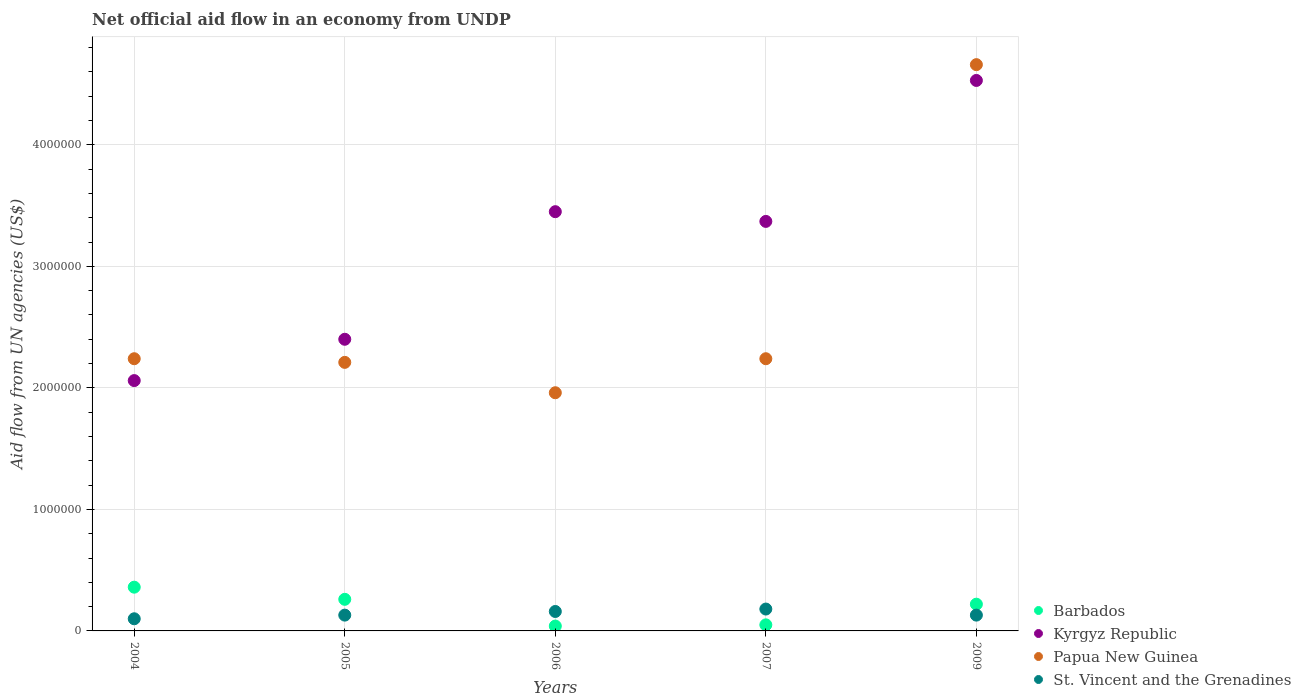Is the number of dotlines equal to the number of legend labels?
Offer a very short reply. Yes. What is the net official aid flow in Papua New Guinea in 2006?
Provide a short and direct response. 1.96e+06. Across all years, what is the minimum net official aid flow in Papua New Guinea?
Ensure brevity in your answer.  1.96e+06. In which year was the net official aid flow in Kyrgyz Republic maximum?
Provide a succinct answer. 2009. What is the total net official aid flow in Papua New Guinea in the graph?
Give a very brief answer. 1.33e+07. What is the difference between the net official aid flow in Barbados in 2004 and that in 2006?
Offer a terse response. 3.20e+05. What is the difference between the net official aid flow in St. Vincent and the Grenadines in 2006 and the net official aid flow in Papua New Guinea in 2005?
Offer a terse response. -2.05e+06. What is the average net official aid flow in Kyrgyz Republic per year?
Give a very brief answer. 3.16e+06. In the year 2004, what is the difference between the net official aid flow in St. Vincent and the Grenadines and net official aid flow in Kyrgyz Republic?
Provide a short and direct response. -1.96e+06. In how many years, is the net official aid flow in Barbados greater than 3200000 US$?
Your answer should be very brief. 0. What is the ratio of the net official aid flow in Kyrgyz Republic in 2006 to that in 2007?
Offer a very short reply. 1.02. Is the difference between the net official aid flow in St. Vincent and the Grenadines in 2004 and 2009 greater than the difference between the net official aid flow in Kyrgyz Republic in 2004 and 2009?
Make the answer very short. Yes. What is the difference between the highest and the second highest net official aid flow in Barbados?
Ensure brevity in your answer.  1.00e+05. Is the sum of the net official aid flow in Kyrgyz Republic in 2006 and 2007 greater than the maximum net official aid flow in Papua New Guinea across all years?
Give a very brief answer. Yes. Is it the case that in every year, the sum of the net official aid flow in Kyrgyz Republic and net official aid flow in Barbados  is greater than the sum of net official aid flow in Papua New Guinea and net official aid flow in St. Vincent and the Grenadines?
Provide a short and direct response. No. Is it the case that in every year, the sum of the net official aid flow in Barbados and net official aid flow in Papua New Guinea  is greater than the net official aid flow in St. Vincent and the Grenadines?
Offer a terse response. Yes. Does the net official aid flow in Papua New Guinea monotonically increase over the years?
Provide a short and direct response. No. Is the net official aid flow in Barbados strictly less than the net official aid flow in Papua New Guinea over the years?
Your answer should be very brief. Yes. Are the values on the major ticks of Y-axis written in scientific E-notation?
Your answer should be very brief. No. How many legend labels are there?
Your answer should be very brief. 4. How are the legend labels stacked?
Give a very brief answer. Vertical. What is the title of the graph?
Provide a succinct answer. Net official aid flow in an economy from UNDP. Does "Slovenia" appear as one of the legend labels in the graph?
Give a very brief answer. No. What is the label or title of the X-axis?
Your answer should be compact. Years. What is the label or title of the Y-axis?
Your answer should be very brief. Aid flow from UN agencies (US$). What is the Aid flow from UN agencies (US$) of Barbados in 2004?
Ensure brevity in your answer.  3.60e+05. What is the Aid flow from UN agencies (US$) of Kyrgyz Republic in 2004?
Give a very brief answer. 2.06e+06. What is the Aid flow from UN agencies (US$) of Papua New Guinea in 2004?
Your answer should be very brief. 2.24e+06. What is the Aid flow from UN agencies (US$) in Kyrgyz Republic in 2005?
Offer a very short reply. 2.40e+06. What is the Aid flow from UN agencies (US$) in Papua New Guinea in 2005?
Ensure brevity in your answer.  2.21e+06. What is the Aid flow from UN agencies (US$) of St. Vincent and the Grenadines in 2005?
Provide a succinct answer. 1.30e+05. What is the Aid flow from UN agencies (US$) of Barbados in 2006?
Your response must be concise. 4.00e+04. What is the Aid flow from UN agencies (US$) of Kyrgyz Republic in 2006?
Ensure brevity in your answer.  3.45e+06. What is the Aid flow from UN agencies (US$) in Papua New Guinea in 2006?
Give a very brief answer. 1.96e+06. What is the Aid flow from UN agencies (US$) of St. Vincent and the Grenadines in 2006?
Provide a succinct answer. 1.60e+05. What is the Aid flow from UN agencies (US$) of Barbados in 2007?
Offer a very short reply. 5.00e+04. What is the Aid flow from UN agencies (US$) in Kyrgyz Republic in 2007?
Ensure brevity in your answer.  3.37e+06. What is the Aid flow from UN agencies (US$) in Papua New Guinea in 2007?
Provide a short and direct response. 2.24e+06. What is the Aid flow from UN agencies (US$) of St. Vincent and the Grenadines in 2007?
Your answer should be compact. 1.80e+05. What is the Aid flow from UN agencies (US$) of Kyrgyz Republic in 2009?
Provide a short and direct response. 4.53e+06. What is the Aid flow from UN agencies (US$) in Papua New Guinea in 2009?
Your answer should be very brief. 4.66e+06. What is the Aid flow from UN agencies (US$) of St. Vincent and the Grenadines in 2009?
Make the answer very short. 1.30e+05. Across all years, what is the maximum Aid flow from UN agencies (US$) of Kyrgyz Republic?
Your answer should be very brief. 4.53e+06. Across all years, what is the maximum Aid flow from UN agencies (US$) of Papua New Guinea?
Offer a very short reply. 4.66e+06. Across all years, what is the maximum Aid flow from UN agencies (US$) of St. Vincent and the Grenadines?
Your response must be concise. 1.80e+05. Across all years, what is the minimum Aid flow from UN agencies (US$) of Kyrgyz Republic?
Your answer should be very brief. 2.06e+06. Across all years, what is the minimum Aid flow from UN agencies (US$) in Papua New Guinea?
Your answer should be compact. 1.96e+06. Across all years, what is the minimum Aid flow from UN agencies (US$) in St. Vincent and the Grenadines?
Your answer should be compact. 1.00e+05. What is the total Aid flow from UN agencies (US$) of Barbados in the graph?
Your answer should be compact. 9.30e+05. What is the total Aid flow from UN agencies (US$) in Kyrgyz Republic in the graph?
Ensure brevity in your answer.  1.58e+07. What is the total Aid flow from UN agencies (US$) of Papua New Guinea in the graph?
Provide a succinct answer. 1.33e+07. What is the total Aid flow from UN agencies (US$) of St. Vincent and the Grenadines in the graph?
Offer a terse response. 7.00e+05. What is the difference between the Aid flow from UN agencies (US$) in Kyrgyz Republic in 2004 and that in 2005?
Give a very brief answer. -3.40e+05. What is the difference between the Aid flow from UN agencies (US$) in Papua New Guinea in 2004 and that in 2005?
Your answer should be very brief. 3.00e+04. What is the difference between the Aid flow from UN agencies (US$) of Kyrgyz Republic in 2004 and that in 2006?
Provide a short and direct response. -1.39e+06. What is the difference between the Aid flow from UN agencies (US$) in Papua New Guinea in 2004 and that in 2006?
Your answer should be very brief. 2.80e+05. What is the difference between the Aid flow from UN agencies (US$) in St. Vincent and the Grenadines in 2004 and that in 2006?
Give a very brief answer. -6.00e+04. What is the difference between the Aid flow from UN agencies (US$) of Barbados in 2004 and that in 2007?
Offer a very short reply. 3.10e+05. What is the difference between the Aid flow from UN agencies (US$) in Kyrgyz Republic in 2004 and that in 2007?
Give a very brief answer. -1.31e+06. What is the difference between the Aid flow from UN agencies (US$) of St. Vincent and the Grenadines in 2004 and that in 2007?
Keep it short and to the point. -8.00e+04. What is the difference between the Aid flow from UN agencies (US$) in Kyrgyz Republic in 2004 and that in 2009?
Provide a succinct answer. -2.47e+06. What is the difference between the Aid flow from UN agencies (US$) in Papua New Guinea in 2004 and that in 2009?
Offer a very short reply. -2.42e+06. What is the difference between the Aid flow from UN agencies (US$) of St. Vincent and the Grenadines in 2004 and that in 2009?
Provide a short and direct response. -3.00e+04. What is the difference between the Aid flow from UN agencies (US$) of Kyrgyz Republic in 2005 and that in 2006?
Give a very brief answer. -1.05e+06. What is the difference between the Aid flow from UN agencies (US$) in Papua New Guinea in 2005 and that in 2006?
Ensure brevity in your answer.  2.50e+05. What is the difference between the Aid flow from UN agencies (US$) of St. Vincent and the Grenadines in 2005 and that in 2006?
Make the answer very short. -3.00e+04. What is the difference between the Aid flow from UN agencies (US$) of Kyrgyz Republic in 2005 and that in 2007?
Your answer should be compact. -9.70e+05. What is the difference between the Aid flow from UN agencies (US$) of St. Vincent and the Grenadines in 2005 and that in 2007?
Give a very brief answer. -5.00e+04. What is the difference between the Aid flow from UN agencies (US$) of Barbados in 2005 and that in 2009?
Your response must be concise. 4.00e+04. What is the difference between the Aid flow from UN agencies (US$) in Kyrgyz Republic in 2005 and that in 2009?
Ensure brevity in your answer.  -2.13e+06. What is the difference between the Aid flow from UN agencies (US$) in Papua New Guinea in 2005 and that in 2009?
Provide a succinct answer. -2.45e+06. What is the difference between the Aid flow from UN agencies (US$) of Barbados in 2006 and that in 2007?
Your answer should be very brief. -10000. What is the difference between the Aid flow from UN agencies (US$) in Papua New Guinea in 2006 and that in 2007?
Offer a very short reply. -2.80e+05. What is the difference between the Aid flow from UN agencies (US$) in St. Vincent and the Grenadines in 2006 and that in 2007?
Provide a short and direct response. -2.00e+04. What is the difference between the Aid flow from UN agencies (US$) of Kyrgyz Republic in 2006 and that in 2009?
Give a very brief answer. -1.08e+06. What is the difference between the Aid flow from UN agencies (US$) in Papua New Guinea in 2006 and that in 2009?
Offer a terse response. -2.70e+06. What is the difference between the Aid flow from UN agencies (US$) of St. Vincent and the Grenadines in 2006 and that in 2009?
Your response must be concise. 3.00e+04. What is the difference between the Aid flow from UN agencies (US$) of Kyrgyz Republic in 2007 and that in 2009?
Offer a very short reply. -1.16e+06. What is the difference between the Aid flow from UN agencies (US$) in Papua New Guinea in 2007 and that in 2009?
Offer a terse response. -2.42e+06. What is the difference between the Aid flow from UN agencies (US$) in St. Vincent and the Grenadines in 2007 and that in 2009?
Provide a succinct answer. 5.00e+04. What is the difference between the Aid flow from UN agencies (US$) in Barbados in 2004 and the Aid flow from UN agencies (US$) in Kyrgyz Republic in 2005?
Offer a very short reply. -2.04e+06. What is the difference between the Aid flow from UN agencies (US$) in Barbados in 2004 and the Aid flow from UN agencies (US$) in Papua New Guinea in 2005?
Provide a succinct answer. -1.85e+06. What is the difference between the Aid flow from UN agencies (US$) in Kyrgyz Republic in 2004 and the Aid flow from UN agencies (US$) in St. Vincent and the Grenadines in 2005?
Ensure brevity in your answer.  1.93e+06. What is the difference between the Aid flow from UN agencies (US$) of Papua New Guinea in 2004 and the Aid flow from UN agencies (US$) of St. Vincent and the Grenadines in 2005?
Give a very brief answer. 2.11e+06. What is the difference between the Aid flow from UN agencies (US$) of Barbados in 2004 and the Aid flow from UN agencies (US$) of Kyrgyz Republic in 2006?
Your answer should be compact. -3.09e+06. What is the difference between the Aid flow from UN agencies (US$) in Barbados in 2004 and the Aid flow from UN agencies (US$) in Papua New Guinea in 2006?
Provide a succinct answer. -1.60e+06. What is the difference between the Aid flow from UN agencies (US$) of Barbados in 2004 and the Aid flow from UN agencies (US$) of St. Vincent and the Grenadines in 2006?
Your answer should be compact. 2.00e+05. What is the difference between the Aid flow from UN agencies (US$) in Kyrgyz Republic in 2004 and the Aid flow from UN agencies (US$) in St. Vincent and the Grenadines in 2006?
Your answer should be very brief. 1.90e+06. What is the difference between the Aid flow from UN agencies (US$) in Papua New Guinea in 2004 and the Aid flow from UN agencies (US$) in St. Vincent and the Grenadines in 2006?
Your answer should be compact. 2.08e+06. What is the difference between the Aid flow from UN agencies (US$) of Barbados in 2004 and the Aid flow from UN agencies (US$) of Kyrgyz Republic in 2007?
Offer a very short reply. -3.01e+06. What is the difference between the Aid flow from UN agencies (US$) of Barbados in 2004 and the Aid flow from UN agencies (US$) of Papua New Guinea in 2007?
Provide a short and direct response. -1.88e+06. What is the difference between the Aid flow from UN agencies (US$) in Barbados in 2004 and the Aid flow from UN agencies (US$) in St. Vincent and the Grenadines in 2007?
Your answer should be very brief. 1.80e+05. What is the difference between the Aid flow from UN agencies (US$) of Kyrgyz Republic in 2004 and the Aid flow from UN agencies (US$) of Papua New Guinea in 2007?
Offer a terse response. -1.80e+05. What is the difference between the Aid flow from UN agencies (US$) of Kyrgyz Republic in 2004 and the Aid flow from UN agencies (US$) of St. Vincent and the Grenadines in 2007?
Your response must be concise. 1.88e+06. What is the difference between the Aid flow from UN agencies (US$) in Papua New Guinea in 2004 and the Aid flow from UN agencies (US$) in St. Vincent and the Grenadines in 2007?
Offer a terse response. 2.06e+06. What is the difference between the Aid flow from UN agencies (US$) in Barbados in 2004 and the Aid flow from UN agencies (US$) in Kyrgyz Republic in 2009?
Your answer should be very brief. -4.17e+06. What is the difference between the Aid flow from UN agencies (US$) in Barbados in 2004 and the Aid flow from UN agencies (US$) in Papua New Guinea in 2009?
Your response must be concise. -4.30e+06. What is the difference between the Aid flow from UN agencies (US$) in Barbados in 2004 and the Aid flow from UN agencies (US$) in St. Vincent and the Grenadines in 2009?
Your response must be concise. 2.30e+05. What is the difference between the Aid flow from UN agencies (US$) of Kyrgyz Republic in 2004 and the Aid flow from UN agencies (US$) of Papua New Guinea in 2009?
Ensure brevity in your answer.  -2.60e+06. What is the difference between the Aid flow from UN agencies (US$) of Kyrgyz Republic in 2004 and the Aid flow from UN agencies (US$) of St. Vincent and the Grenadines in 2009?
Ensure brevity in your answer.  1.93e+06. What is the difference between the Aid flow from UN agencies (US$) in Papua New Guinea in 2004 and the Aid flow from UN agencies (US$) in St. Vincent and the Grenadines in 2009?
Your answer should be very brief. 2.11e+06. What is the difference between the Aid flow from UN agencies (US$) in Barbados in 2005 and the Aid flow from UN agencies (US$) in Kyrgyz Republic in 2006?
Your answer should be very brief. -3.19e+06. What is the difference between the Aid flow from UN agencies (US$) of Barbados in 2005 and the Aid flow from UN agencies (US$) of Papua New Guinea in 2006?
Your response must be concise. -1.70e+06. What is the difference between the Aid flow from UN agencies (US$) of Kyrgyz Republic in 2005 and the Aid flow from UN agencies (US$) of Papua New Guinea in 2006?
Your answer should be compact. 4.40e+05. What is the difference between the Aid flow from UN agencies (US$) in Kyrgyz Republic in 2005 and the Aid flow from UN agencies (US$) in St. Vincent and the Grenadines in 2006?
Provide a succinct answer. 2.24e+06. What is the difference between the Aid flow from UN agencies (US$) in Papua New Guinea in 2005 and the Aid flow from UN agencies (US$) in St. Vincent and the Grenadines in 2006?
Your response must be concise. 2.05e+06. What is the difference between the Aid flow from UN agencies (US$) in Barbados in 2005 and the Aid flow from UN agencies (US$) in Kyrgyz Republic in 2007?
Make the answer very short. -3.11e+06. What is the difference between the Aid flow from UN agencies (US$) in Barbados in 2005 and the Aid flow from UN agencies (US$) in Papua New Guinea in 2007?
Provide a succinct answer. -1.98e+06. What is the difference between the Aid flow from UN agencies (US$) in Kyrgyz Republic in 2005 and the Aid flow from UN agencies (US$) in Papua New Guinea in 2007?
Your answer should be very brief. 1.60e+05. What is the difference between the Aid flow from UN agencies (US$) in Kyrgyz Republic in 2005 and the Aid flow from UN agencies (US$) in St. Vincent and the Grenadines in 2007?
Provide a succinct answer. 2.22e+06. What is the difference between the Aid flow from UN agencies (US$) of Papua New Guinea in 2005 and the Aid flow from UN agencies (US$) of St. Vincent and the Grenadines in 2007?
Keep it short and to the point. 2.03e+06. What is the difference between the Aid flow from UN agencies (US$) in Barbados in 2005 and the Aid flow from UN agencies (US$) in Kyrgyz Republic in 2009?
Ensure brevity in your answer.  -4.27e+06. What is the difference between the Aid flow from UN agencies (US$) in Barbados in 2005 and the Aid flow from UN agencies (US$) in Papua New Guinea in 2009?
Keep it short and to the point. -4.40e+06. What is the difference between the Aid flow from UN agencies (US$) of Kyrgyz Republic in 2005 and the Aid flow from UN agencies (US$) of Papua New Guinea in 2009?
Your answer should be very brief. -2.26e+06. What is the difference between the Aid flow from UN agencies (US$) of Kyrgyz Republic in 2005 and the Aid flow from UN agencies (US$) of St. Vincent and the Grenadines in 2009?
Offer a very short reply. 2.27e+06. What is the difference between the Aid flow from UN agencies (US$) of Papua New Guinea in 2005 and the Aid flow from UN agencies (US$) of St. Vincent and the Grenadines in 2009?
Provide a succinct answer. 2.08e+06. What is the difference between the Aid flow from UN agencies (US$) in Barbados in 2006 and the Aid flow from UN agencies (US$) in Kyrgyz Republic in 2007?
Offer a very short reply. -3.33e+06. What is the difference between the Aid flow from UN agencies (US$) in Barbados in 2006 and the Aid flow from UN agencies (US$) in Papua New Guinea in 2007?
Give a very brief answer. -2.20e+06. What is the difference between the Aid flow from UN agencies (US$) of Kyrgyz Republic in 2006 and the Aid flow from UN agencies (US$) of Papua New Guinea in 2007?
Make the answer very short. 1.21e+06. What is the difference between the Aid flow from UN agencies (US$) in Kyrgyz Republic in 2006 and the Aid flow from UN agencies (US$) in St. Vincent and the Grenadines in 2007?
Ensure brevity in your answer.  3.27e+06. What is the difference between the Aid flow from UN agencies (US$) of Papua New Guinea in 2006 and the Aid flow from UN agencies (US$) of St. Vincent and the Grenadines in 2007?
Provide a short and direct response. 1.78e+06. What is the difference between the Aid flow from UN agencies (US$) of Barbados in 2006 and the Aid flow from UN agencies (US$) of Kyrgyz Republic in 2009?
Offer a terse response. -4.49e+06. What is the difference between the Aid flow from UN agencies (US$) in Barbados in 2006 and the Aid flow from UN agencies (US$) in Papua New Guinea in 2009?
Offer a terse response. -4.62e+06. What is the difference between the Aid flow from UN agencies (US$) in Kyrgyz Republic in 2006 and the Aid flow from UN agencies (US$) in Papua New Guinea in 2009?
Provide a short and direct response. -1.21e+06. What is the difference between the Aid flow from UN agencies (US$) of Kyrgyz Republic in 2006 and the Aid flow from UN agencies (US$) of St. Vincent and the Grenadines in 2009?
Provide a short and direct response. 3.32e+06. What is the difference between the Aid flow from UN agencies (US$) in Papua New Guinea in 2006 and the Aid flow from UN agencies (US$) in St. Vincent and the Grenadines in 2009?
Offer a terse response. 1.83e+06. What is the difference between the Aid flow from UN agencies (US$) of Barbados in 2007 and the Aid flow from UN agencies (US$) of Kyrgyz Republic in 2009?
Your answer should be very brief. -4.48e+06. What is the difference between the Aid flow from UN agencies (US$) in Barbados in 2007 and the Aid flow from UN agencies (US$) in Papua New Guinea in 2009?
Offer a very short reply. -4.61e+06. What is the difference between the Aid flow from UN agencies (US$) in Kyrgyz Republic in 2007 and the Aid flow from UN agencies (US$) in Papua New Guinea in 2009?
Your answer should be very brief. -1.29e+06. What is the difference between the Aid flow from UN agencies (US$) in Kyrgyz Republic in 2007 and the Aid flow from UN agencies (US$) in St. Vincent and the Grenadines in 2009?
Give a very brief answer. 3.24e+06. What is the difference between the Aid flow from UN agencies (US$) of Papua New Guinea in 2007 and the Aid flow from UN agencies (US$) of St. Vincent and the Grenadines in 2009?
Your answer should be compact. 2.11e+06. What is the average Aid flow from UN agencies (US$) of Barbados per year?
Your answer should be very brief. 1.86e+05. What is the average Aid flow from UN agencies (US$) in Kyrgyz Republic per year?
Give a very brief answer. 3.16e+06. What is the average Aid flow from UN agencies (US$) in Papua New Guinea per year?
Give a very brief answer. 2.66e+06. In the year 2004, what is the difference between the Aid flow from UN agencies (US$) of Barbados and Aid flow from UN agencies (US$) of Kyrgyz Republic?
Provide a short and direct response. -1.70e+06. In the year 2004, what is the difference between the Aid flow from UN agencies (US$) of Barbados and Aid flow from UN agencies (US$) of Papua New Guinea?
Offer a terse response. -1.88e+06. In the year 2004, what is the difference between the Aid flow from UN agencies (US$) of Barbados and Aid flow from UN agencies (US$) of St. Vincent and the Grenadines?
Ensure brevity in your answer.  2.60e+05. In the year 2004, what is the difference between the Aid flow from UN agencies (US$) of Kyrgyz Republic and Aid flow from UN agencies (US$) of St. Vincent and the Grenadines?
Your answer should be very brief. 1.96e+06. In the year 2004, what is the difference between the Aid flow from UN agencies (US$) in Papua New Guinea and Aid flow from UN agencies (US$) in St. Vincent and the Grenadines?
Offer a very short reply. 2.14e+06. In the year 2005, what is the difference between the Aid flow from UN agencies (US$) of Barbados and Aid flow from UN agencies (US$) of Kyrgyz Republic?
Provide a short and direct response. -2.14e+06. In the year 2005, what is the difference between the Aid flow from UN agencies (US$) in Barbados and Aid flow from UN agencies (US$) in Papua New Guinea?
Your response must be concise. -1.95e+06. In the year 2005, what is the difference between the Aid flow from UN agencies (US$) in Kyrgyz Republic and Aid flow from UN agencies (US$) in Papua New Guinea?
Provide a short and direct response. 1.90e+05. In the year 2005, what is the difference between the Aid flow from UN agencies (US$) of Kyrgyz Republic and Aid flow from UN agencies (US$) of St. Vincent and the Grenadines?
Keep it short and to the point. 2.27e+06. In the year 2005, what is the difference between the Aid flow from UN agencies (US$) in Papua New Guinea and Aid flow from UN agencies (US$) in St. Vincent and the Grenadines?
Keep it short and to the point. 2.08e+06. In the year 2006, what is the difference between the Aid flow from UN agencies (US$) of Barbados and Aid flow from UN agencies (US$) of Kyrgyz Republic?
Your response must be concise. -3.41e+06. In the year 2006, what is the difference between the Aid flow from UN agencies (US$) of Barbados and Aid flow from UN agencies (US$) of Papua New Guinea?
Your response must be concise. -1.92e+06. In the year 2006, what is the difference between the Aid flow from UN agencies (US$) of Kyrgyz Republic and Aid flow from UN agencies (US$) of Papua New Guinea?
Your answer should be compact. 1.49e+06. In the year 2006, what is the difference between the Aid flow from UN agencies (US$) in Kyrgyz Republic and Aid flow from UN agencies (US$) in St. Vincent and the Grenadines?
Offer a terse response. 3.29e+06. In the year 2006, what is the difference between the Aid flow from UN agencies (US$) of Papua New Guinea and Aid flow from UN agencies (US$) of St. Vincent and the Grenadines?
Provide a short and direct response. 1.80e+06. In the year 2007, what is the difference between the Aid flow from UN agencies (US$) in Barbados and Aid flow from UN agencies (US$) in Kyrgyz Republic?
Ensure brevity in your answer.  -3.32e+06. In the year 2007, what is the difference between the Aid flow from UN agencies (US$) in Barbados and Aid flow from UN agencies (US$) in Papua New Guinea?
Keep it short and to the point. -2.19e+06. In the year 2007, what is the difference between the Aid flow from UN agencies (US$) of Kyrgyz Republic and Aid flow from UN agencies (US$) of Papua New Guinea?
Your answer should be very brief. 1.13e+06. In the year 2007, what is the difference between the Aid flow from UN agencies (US$) of Kyrgyz Republic and Aid flow from UN agencies (US$) of St. Vincent and the Grenadines?
Offer a terse response. 3.19e+06. In the year 2007, what is the difference between the Aid flow from UN agencies (US$) in Papua New Guinea and Aid flow from UN agencies (US$) in St. Vincent and the Grenadines?
Your answer should be very brief. 2.06e+06. In the year 2009, what is the difference between the Aid flow from UN agencies (US$) in Barbados and Aid flow from UN agencies (US$) in Kyrgyz Republic?
Ensure brevity in your answer.  -4.31e+06. In the year 2009, what is the difference between the Aid flow from UN agencies (US$) in Barbados and Aid flow from UN agencies (US$) in Papua New Guinea?
Keep it short and to the point. -4.44e+06. In the year 2009, what is the difference between the Aid flow from UN agencies (US$) in Barbados and Aid flow from UN agencies (US$) in St. Vincent and the Grenadines?
Provide a short and direct response. 9.00e+04. In the year 2009, what is the difference between the Aid flow from UN agencies (US$) in Kyrgyz Republic and Aid flow from UN agencies (US$) in Papua New Guinea?
Your answer should be very brief. -1.30e+05. In the year 2009, what is the difference between the Aid flow from UN agencies (US$) of Kyrgyz Republic and Aid flow from UN agencies (US$) of St. Vincent and the Grenadines?
Offer a terse response. 4.40e+06. In the year 2009, what is the difference between the Aid flow from UN agencies (US$) of Papua New Guinea and Aid flow from UN agencies (US$) of St. Vincent and the Grenadines?
Ensure brevity in your answer.  4.53e+06. What is the ratio of the Aid flow from UN agencies (US$) in Barbados in 2004 to that in 2005?
Give a very brief answer. 1.38. What is the ratio of the Aid flow from UN agencies (US$) of Kyrgyz Republic in 2004 to that in 2005?
Your answer should be very brief. 0.86. What is the ratio of the Aid flow from UN agencies (US$) in Papua New Guinea in 2004 to that in 2005?
Provide a succinct answer. 1.01. What is the ratio of the Aid flow from UN agencies (US$) of St. Vincent and the Grenadines in 2004 to that in 2005?
Your answer should be very brief. 0.77. What is the ratio of the Aid flow from UN agencies (US$) of Kyrgyz Republic in 2004 to that in 2006?
Your response must be concise. 0.6. What is the ratio of the Aid flow from UN agencies (US$) in Barbados in 2004 to that in 2007?
Ensure brevity in your answer.  7.2. What is the ratio of the Aid flow from UN agencies (US$) of Kyrgyz Republic in 2004 to that in 2007?
Offer a very short reply. 0.61. What is the ratio of the Aid flow from UN agencies (US$) of St. Vincent and the Grenadines in 2004 to that in 2007?
Ensure brevity in your answer.  0.56. What is the ratio of the Aid flow from UN agencies (US$) of Barbados in 2004 to that in 2009?
Offer a terse response. 1.64. What is the ratio of the Aid flow from UN agencies (US$) in Kyrgyz Republic in 2004 to that in 2009?
Give a very brief answer. 0.45. What is the ratio of the Aid flow from UN agencies (US$) in Papua New Guinea in 2004 to that in 2009?
Your answer should be compact. 0.48. What is the ratio of the Aid flow from UN agencies (US$) in St. Vincent and the Grenadines in 2004 to that in 2009?
Offer a terse response. 0.77. What is the ratio of the Aid flow from UN agencies (US$) in Kyrgyz Republic in 2005 to that in 2006?
Provide a succinct answer. 0.7. What is the ratio of the Aid flow from UN agencies (US$) in Papua New Guinea in 2005 to that in 2006?
Offer a terse response. 1.13. What is the ratio of the Aid flow from UN agencies (US$) in St. Vincent and the Grenadines in 2005 to that in 2006?
Offer a terse response. 0.81. What is the ratio of the Aid flow from UN agencies (US$) of Kyrgyz Republic in 2005 to that in 2007?
Make the answer very short. 0.71. What is the ratio of the Aid flow from UN agencies (US$) of Papua New Guinea in 2005 to that in 2007?
Provide a short and direct response. 0.99. What is the ratio of the Aid flow from UN agencies (US$) in St. Vincent and the Grenadines in 2005 to that in 2007?
Offer a very short reply. 0.72. What is the ratio of the Aid flow from UN agencies (US$) in Barbados in 2005 to that in 2009?
Keep it short and to the point. 1.18. What is the ratio of the Aid flow from UN agencies (US$) of Kyrgyz Republic in 2005 to that in 2009?
Your response must be concise. 0.53. What is the ratio of the Aid flow from UN agencies (US$) in Papua New Guinea in 2005 to that in 2009?
Make the answer very short. 0.47. What is the ratio of the Aid flow from UN agencies (US$) in St. Vincent and the Grenadines in 2005 to that in 2009?
Keep it short and to the point. 1. What is the ratio of the Aid flow from UN agencies (US$) in Kyrgyz Republic in 2006 to that in 2007?
Offer a very short reply. 1.02. What is the ratio of the Aid flow from UN agencies (US$) in Barbados in 2006 to that in 2009?
Your response must be concise. 0.18. What is the ratio of the Aid flow from UN agencies (US$) in Kyrgyz Republic in 2006 to that in 2009?
Offer a very short reply. 0.76. What is the ratio of the Aid flow from UN agencies (US$) in Papua New Guinea in 2006 to that in 2009?
Offer a very short reply. 0.42. What is the ratio of the Aid flow from UN agencies (US$) of St. Vincent and the Grenadines in 2006 to that in 2009?
Your answer should be very brief. 1.23. What is the ratio of the Aid flow from UN agencies (US$) of Barbados in 2007 to that in 2009?
Keep it short and to the point. 0.23. What is the ratio of the Aid flow from UN agencies (US$) in Kyrgyz Republic in 2007 to that in 2009?
Offer a terse response. 0.74. What is the ratio of the Aid flow from UN agencies (US$) in Papua New Guinea in 2007 to that in 2009?
Offer a very short reply. 0.48. What is the ratio of the Aid flow from UN agencies (US$) of St. Vincent and the Grenadines in 2007 to that in 2009?
Your answer should be very brief. 1.38. What is the difference between the highest and the second highest Aid flow from UN agencies (US$) of Barbados?
Keep it short and to the point. 1.00e+05. What is the difference between the highest and the second highest Aid flow from UN agencies (US$) of Kyrgyz Republic?
Offer a terse response. 1.08e+06. What is the difference between the highest and the second highest Aid flow from UN agencies (US$) in Papua New Guinea?
Offer a very short reply. 2.42e+06. What is the difference between the highest and the lowest Aid flow from UN agencies (US$) of Kyrgyz Republic?
Your answer should be very brief. 2.47e+06. What is the difference between the highest and the lowest Aid flow from UN agencies (US$) of Papua New Guinea?
Provide a short and direct response. 2.70e+06. What is the difference between the highest and the lowest Aid flow from UN agencies (US$) in St. Vincent and the Grenadines?
Offer a terse response. 8.00e+04. 